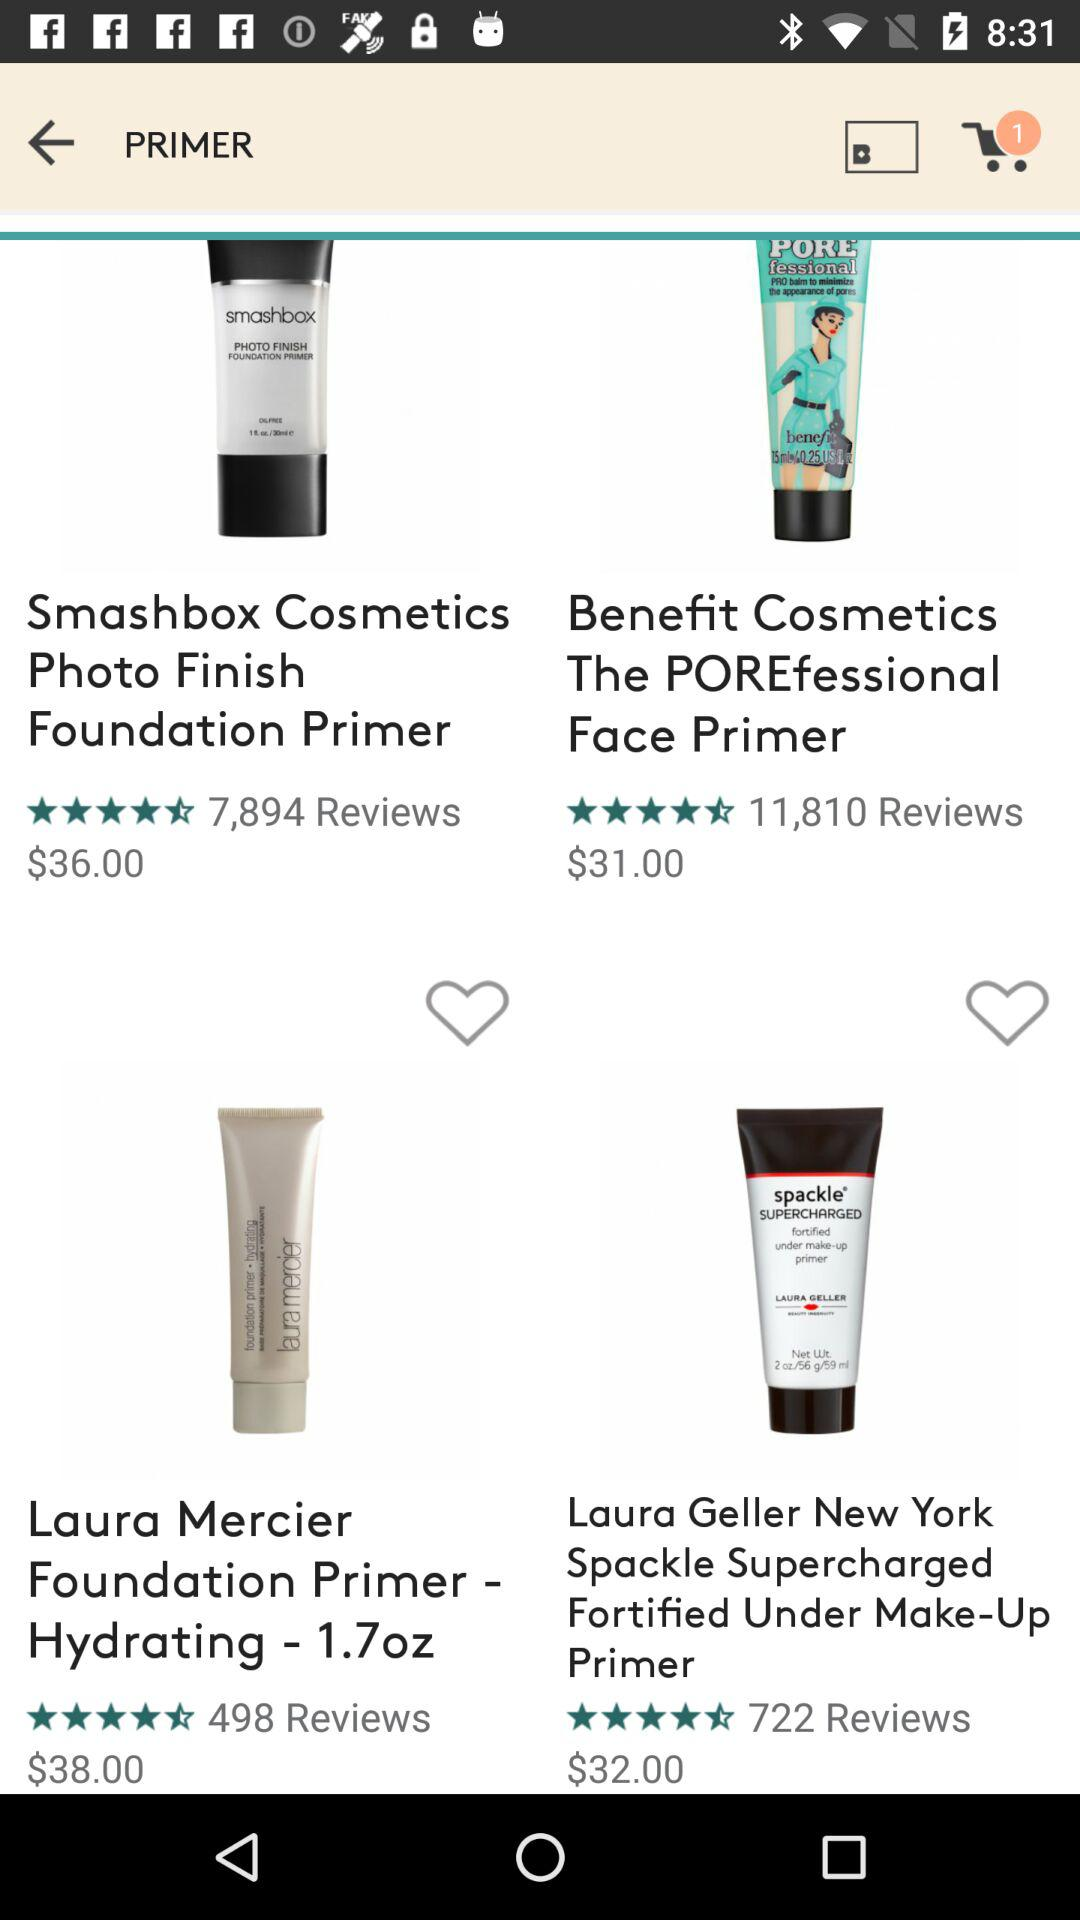How many ratings does the "Benefit Cosmetics The POREfessional Face Primer" have out of 5? The rating is 4.5 stars. 